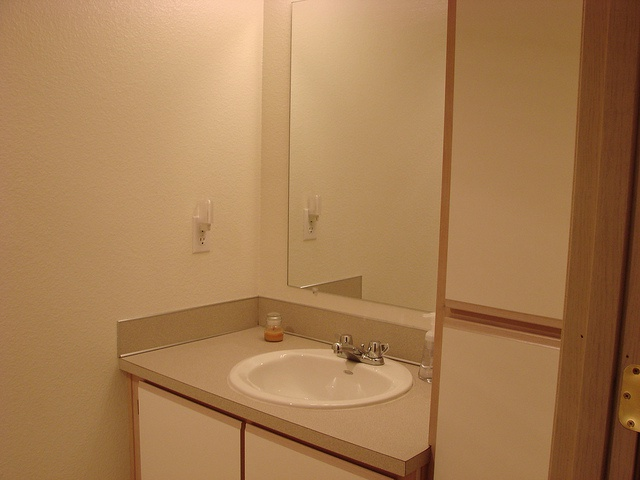Describe the objects in this image and their specific colors. I can see a sink in gray and tan tones in this image. 